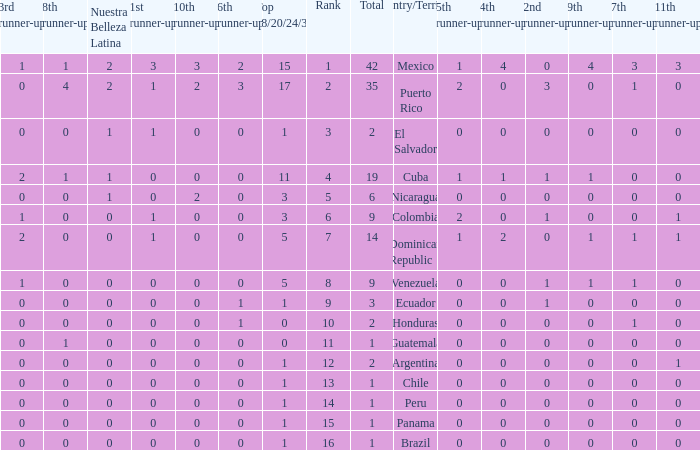What is the average total of the country with a 4th runner-up of 0 and a Nuestra Bellaza Latina less than 0? None. 